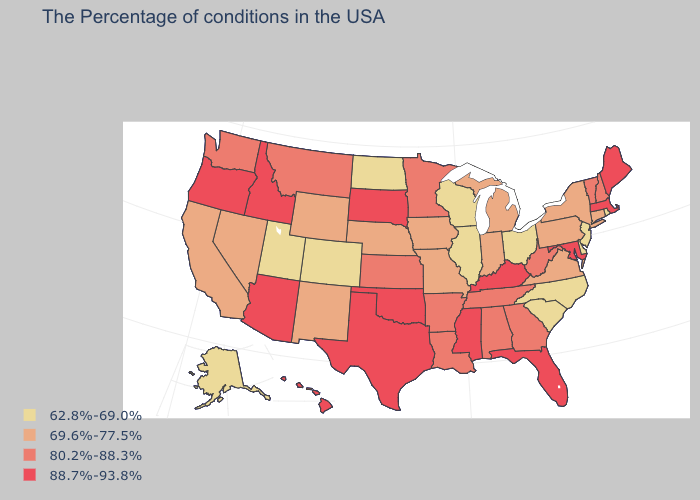Name the states that have a value in the range 69.6%-77.5%?
Give a very brief answer. Connecticut, New York, Pennsylvania, Virginia, Michigan, Indiana, Missouri, Iowa, Nebraska, Wyoming, New Mexico, Nevada, California. Name the states that have a value in the range 62.8%-69.0%?
Concise answer only. Rhode Island, New Jersey, Delaware, North Carolina, South Carolina, Ohio, Wisconsin, Illinois, North Dakota, Colorado, Utah, Alaska. What is the highest value in states that border Ohio?
Keep it brief. 88.7%-93.8%. Which states have the lowest value in the USA?
Concise answer only. Rhode Island, New Jersey, Delaware, North Carolina, South Carolina, Ohio, Wisconsin, Illinois, North Dakota, Colorado, Utah, Alaska. Which states have the lowest value in the USA?
Quick response, please. Rhode Island, New Jersey, Delaware, North Carolina, South Carolina, Ohio, Wisconsin, Illinois, North Dakota, Colorado, Utah, Alaska. Name the states that have a value in the range 88.7%-93.8%?
Concise answer only. Maine, Massachusetts, Maryland, Florida, Kentucky, Mississippi, Oklahoma, Texas, South Dakota, Arizona, Idaho, Oregon, Hawaii. What is the highest value in the USA?
Answer briefly. 88.7%-93.8%. What is the lowest value in states that border Illinois?
Quick response, please. 62.8%-69.0%. What is the value of New York?
Write a very short answer. 69.6%-77.5%. Among the states that border West Virginia , does Ohio have the lowest value?
Answer briefly. Yes. What is the highest value in states that border Arizona?
Concise answer only. 69.6%-77.5%. Name the states that have a value in the range 80.2%-88.3%?
Keep it brief. New Hampshire, Vermont, West Virginia, Georgia, Alabama, Tennessee, Louisiana, Arkansas, Minnesota, Kansas, Montana, Washington. What is the value of Nevada?
Give a very brief answer. 69.6%-77.5%. What is the value of Montana?
Write a very short answer. 80.2%-88.3%. Does the first symbol in the legend represent the smallest category?
Be succinct. Yes. 